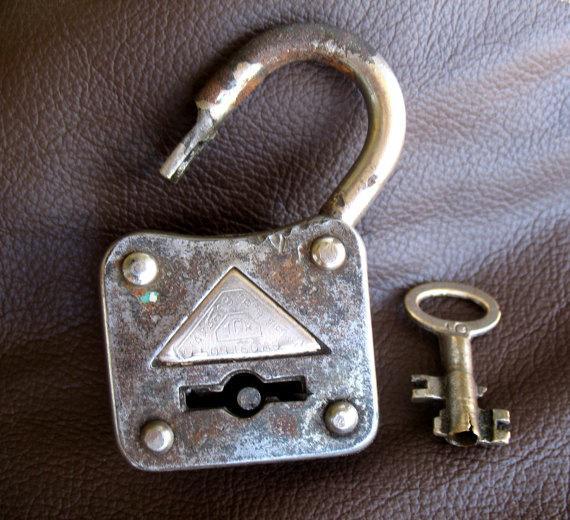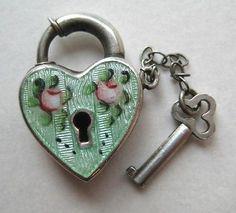The first image is the image on the left, the second image is the image on the right. Given the left and right images, does the statement "The lock in the image on the right is in the locked position." hold true? Answer yes or no. Yes. The first image is the image on the left, the second image is the image on the right. Evaluate the accuracy of this statement regarding the images: "An image of an antique-looking lock and key set includes a heart-shaped element.". Is it true? Answer yes or no. Yes. 